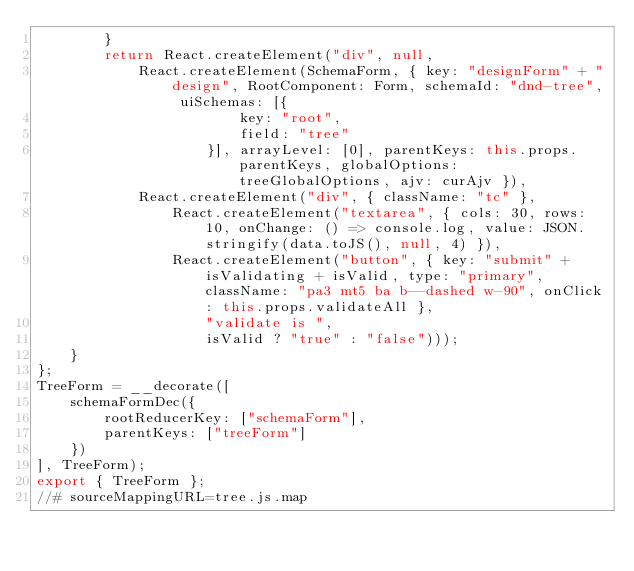Convert code to text. <code><loc_0><loc_0><loc_500><loc_500><_JavaScript_>        }
        return React.createElement("div", null,
            React.createElement(SchemaForm, { key: "designForm" + "design", RootComponent: Form, schemaId: "dnd-tree", uiSchemas: [{
                        key: "root",
                        field: "tree"
                    }], arrayLevel: [0], parentKeys: this.props.parentKeys, globalOptions: treeGlobalOptions, ajv: curAjv }),
            React.createElement("div", { className: "tc" },
                React.createElement("textarea", { cols: 30, rows: 10, onChange: () => console.log, value: JSON.stringify(data.toJS(), null, 4) }),
                React.createElement("button", { key: "submit" + isValidating + isValid, type: "primary", className: "pa3 mt5 ba b--dashed w-90", onClick: this.props.validateAll },
                    "validate is ",
                    isValid ? "true" : "false")));
    }
};
TreeForm = __decorate([
    schemaFormDec({
        rootReducerKey: ["schemaForm"],
        parentKeys: ["treeForm"]
    })
], TreeForm);
export { TreeForm };
//# sourceMappingURL=tree.js.map</code> 